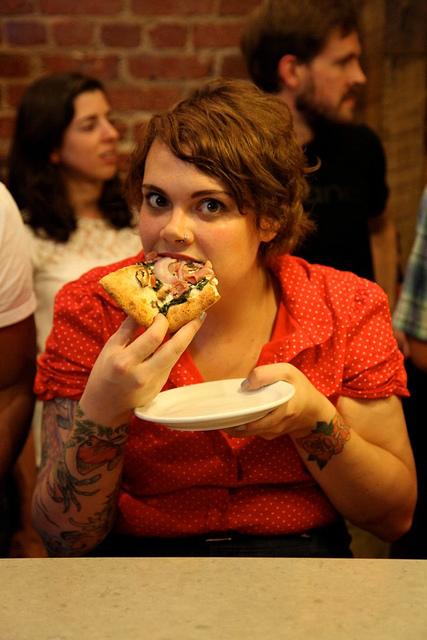Are all the people taking pictures?
Write a very short answer. No. What is on the woman's arms?
Write a very short answer. Tattoos. Is this woman done getting tattoos yet?
Write a very short answer. No. Are the people intoxicated?
Give a very brief answer. No. Is the girl hungry?
Be succinct. Yes. 